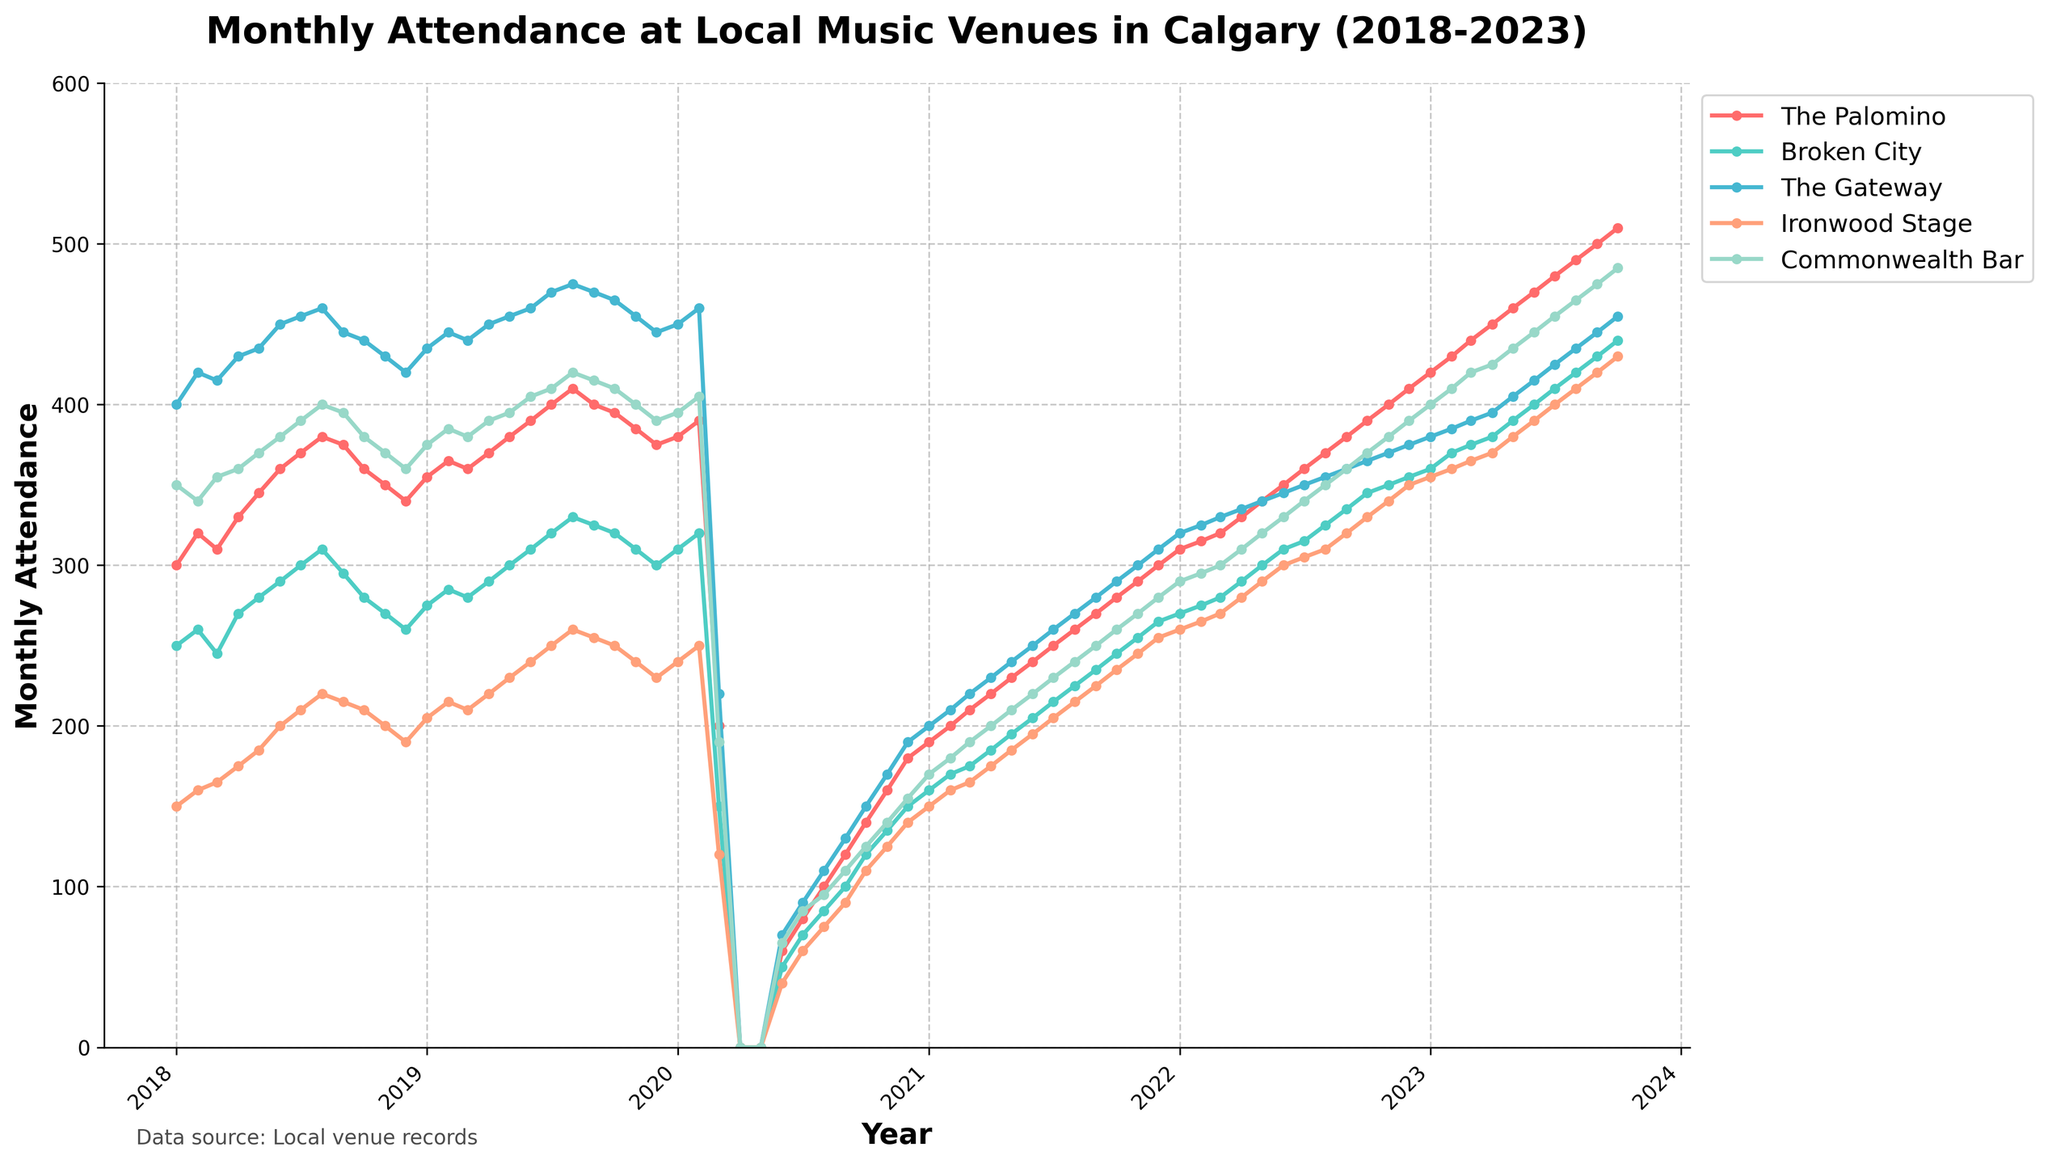What is the title of the plot? The title is displayed at the top of the plot and provides an overview of the data.
Answer: Monthly Attendance at Local Music Venues in Calgary (2018-2023) Which venue had the lowest attendance in April 2020? In April 2020, the lines representing each venue's attendance intersect at the x-axis, all reaching a value of zero.
Answer: All venues had zero attendance in April 2020 Which venue showed a consistent increase in attendance every month from January 2018 to February 2019? Looking at the trajectory of the lines in the plot, the venue with a steady upward trend in attendance over this period is The Palomino.
Answer: The Palomino What was the attendance at The Gateway in March 2020, and why is it significant? In March 2020, The Gateway's data points show a sharp decline in attendance due to possible external events impacting all venues. The attendance for The Gateway was around 220.
Answer: 220 What was the approximate attendance difference between The Palomino and Commonwealth Bar in July 2023? To determine the difference, locate the data points for July 2023 for both venues and subtract Commonwealth Bar's attendance (455) from The Palomino's attendance (480). (480 - 455)
Answer: 25 Did any venue return to pre-pandemic attendance levels by the end of 2023? To assess this, compare the attendance figures for December 2019 with those in December 2023. The lines in December 2023 are notably higher than in December 2019 for all venues, indicating a return to or surpassing of pre-pandemic levels.
Answer: Yes Which venue had the most volatile attendance from 2018 to 2023? Volatility can be identified by the number of significant ups and downs in the plot. The Gateway shows the most fluctuations within the time frame.
Answer: The Gateway What was the average monthly attendance at Ironwood Stage in 2022? To find the average, locate the monthly data points for Ironwood Stage in 2022 and calculate (260 + 265 + 270 + 280 + 290 + 300 + 305 + 310 + 320 + 330 + 340 + 350)/12. The result of 3550/12 equals approximately 295.83.
Answer: 295.83 Which venue experienced the sharpest drop in attendance in March 2020? The lines drop significantly for all venues in March 2020, but for The Palomino, the drop from February to March 2020 is the steepest.
Answer: The Palomino 